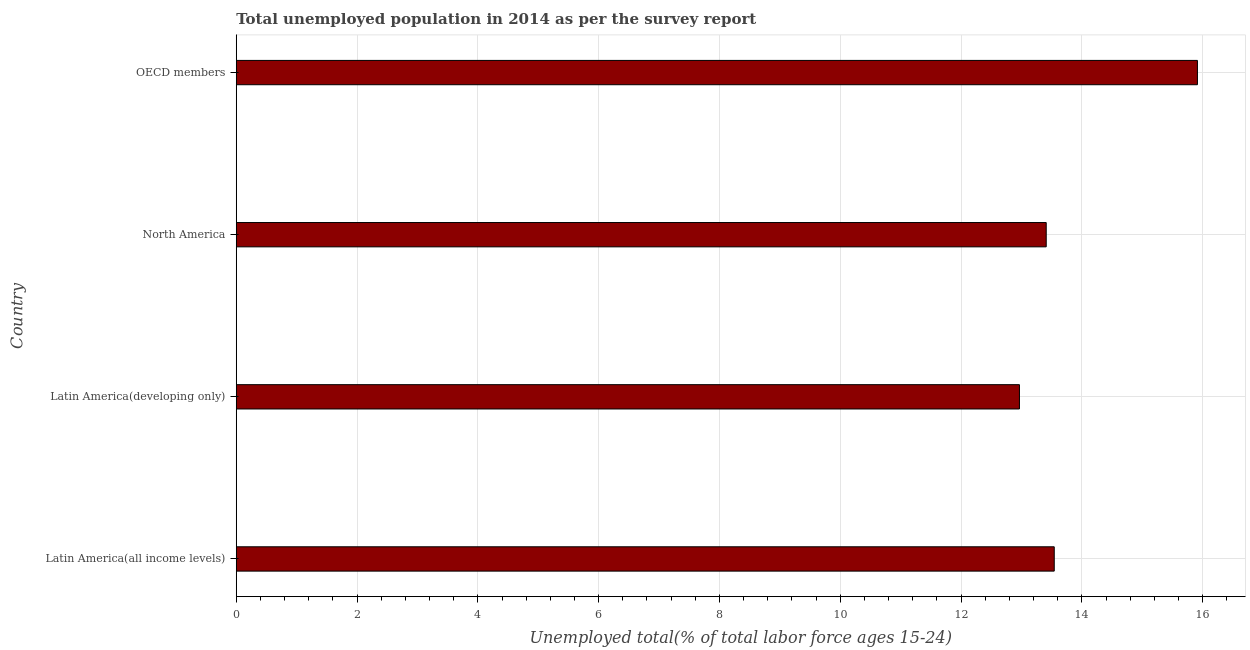Does the graph contain grids?
Ensure brevity in your answer.  Yes. What is the title of the graph?
Ensure brevity in your answer.  Total unemployed population in 2014 as per the survey report. What is the label or title of the X-axis?
Make the answer very short. Unemployed total(% of total labor force ages 15-24). What is the label or title of the Y-axis?
Provide a succinct answer. Country. What is the unemployed youth in North America?
Provide a short and direct response. 13.41. Across all countries, what is the maximum unemployed youth?
Your answer should be very brief. 15.91. Across all countries, what is the minimum unemployed youth?
Your answer should be compact. 12.97. In which country was the unemployed youth minimum?
Provide a succinct answer. Latin America(developing only). What is the sum of the unemployed youth?
Offer a terse response. 55.83. What is the difference between the unemployed youth in Latin America(developing only) and OECD members?
Keep it short and to the point. -2.95. What is the average unemployed youth per country?
Ensure brevity in your answer.  13.96. What is the median unemployed youth?
Offer a very short reply. 13.48. In how many countries, is the unemployed youth greater than 0.4 %?
Provide a short and direct response. 4. What is the difference between the highest and the second highest unemployed youth?
Keep it short and to the point. 2.37. What is the difference between the highest and the lowest unemployed youth?
Provide a short and direct response. 2.95. In how many countries, is the unemployed youth greater than the average unemployed youth taken over all countries?
Make the answer very short. 1. How many countries are there in the graph?
Your response must be concise. 4. What is the Unemployed total(% of total labor force ages 15-24) in Latin America(all income levels)?
Your answer should be compact. 13.54. What is the Unemployed total(% of total labor force ages 15-24) in Latin America(developing only)?
Keep it short and to the point. 12.97. What is the Unemployed total(% of total labor force ages 15-24) in North America?
Offer a very short reply. 13.41. What is the Unemployed total(% of total labor force ages 15-24) of OECD members?
Your answer should be very brief. 15.91. What is the difference between the Unemployed total(% of total labor force ages 15-24) in Latin America(all income levels) and Latin America(developing only)?
Your answer should be very brief. 0.58. What is the difference between the Unemployed total(% of total labor force ages 15-24) in Latin America(all income levels) and North America?
Ensure brevity in your answer.  0.13. What is the difference between the Unemployed total(% of total labor force ages 15-24) in Latin America(all income levels) and OECD members?
Give a very brief answer. -2.37. What is the difference between the Unemployed total(% of total labor force ages 15-24) in Latin America(developing only) and North America?
Ensure brevity in your answer.  -0.44. What is the difference between the Unemployed total(% of total labor force ages 15-24) in Latin America(developing only) and OECD members?
Provide a succinct answer. -2.95. What is the difference between the Unemployed total(% of total labor force ages 15-24) in North America and OECD members?
Ensure brevity in your answer.  -2.5. What is the ratio of the Unemployed total(% of total labor force ages 15-24) in Latin America(all income levels) to that in Latin America(developing only)?
Offer a very short reply. 1.04. What is the ratio of the Unemployed total(% of total labor force ages 15-24) in Latin America(all income levels) to that in North America?
Ensure brevity in your answer.  1.01. What is the ratio of the Unemployed total(% of total labor force ages 15-24) in Latin America(all income levels) to that in OECD members?
Give a very brief answer. 0.85. What is the ratio of the Unemployed total(% of total labor force ages 15-24) in Latin America(developing only) to that in OECD members?
Your answer should be compact. 0.81. What is the ratio of the Unemployed total(% of total labor force ages 15-24) in North America to that in OECD members?
Your answer should be compact. 0.84. 